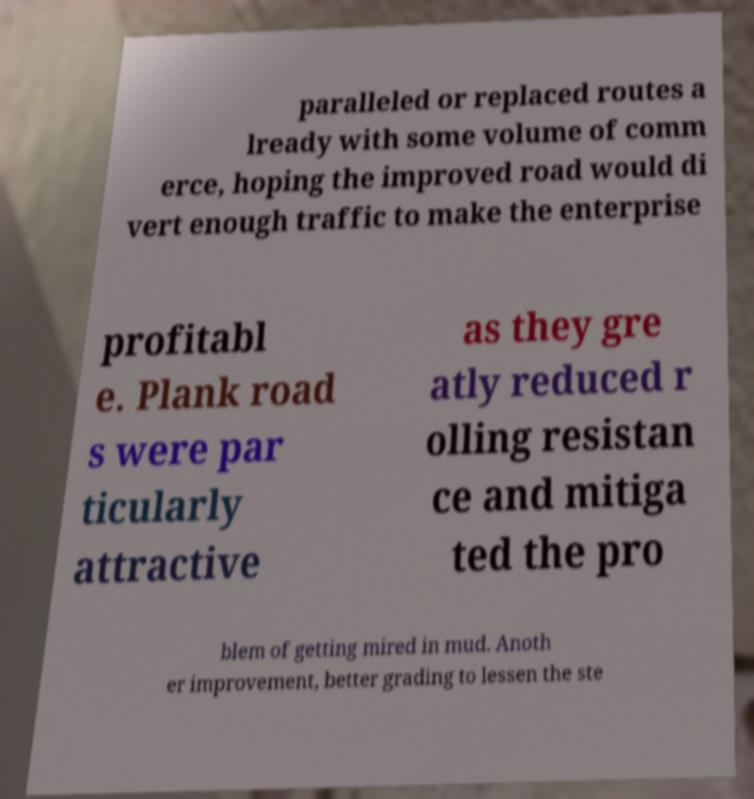Can you read and provide the text displayed in the image?This photo seems to have some interesting text. Can you extract and type it out for me? paralleled or replaced routes a lready with some volume of comm erce, hoping the improved road would di vert enough traffic to make the enterprise profitabl e. Plank road s were par ticularly attractive as they gre atly reduced r olling resistan ce and mitiga ted the pro blem of getting mired in mud. Anoth er improvement, better grading to lessen the ste 